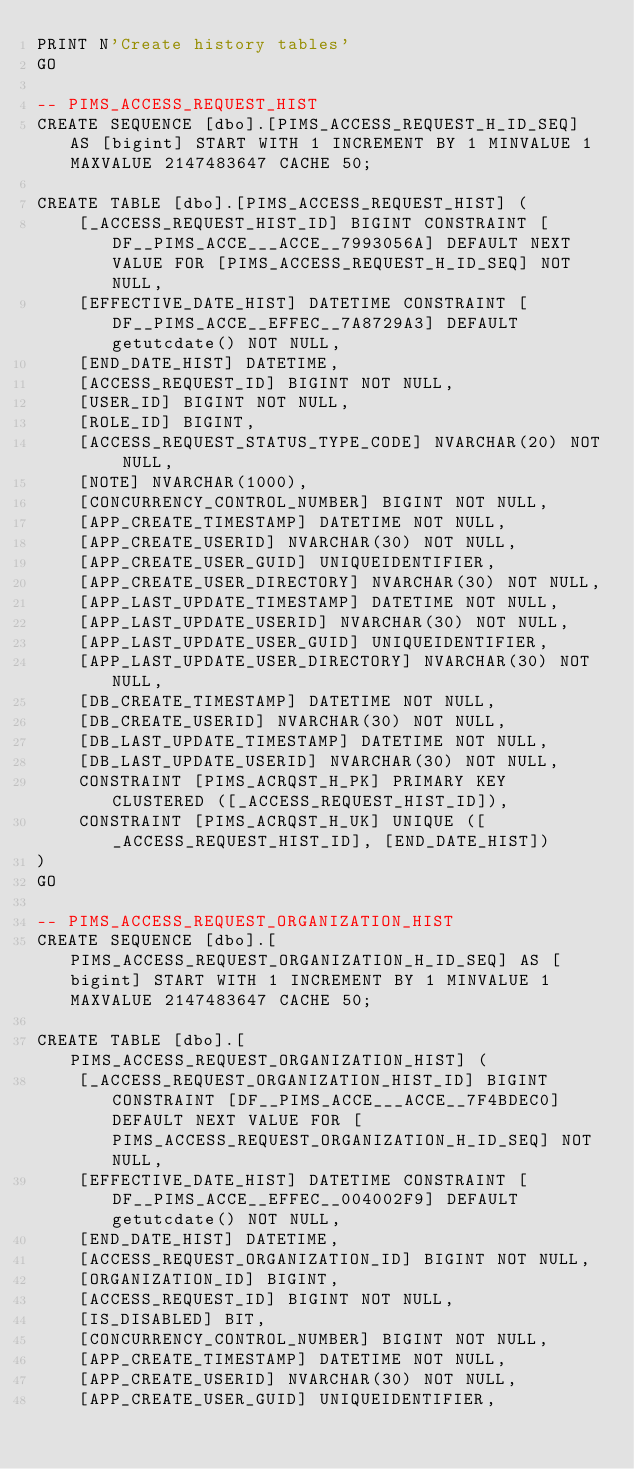<code> <loc_0><loc_0><loc_500><loc_500><_SQL_>PRINT N'Create history tables'
GO

-- PIMS_ACCESS_REQUEST_HIST
CREATE SEQUENCE [dbo].[PIMS_ACCESS_REQUEST_H_ID_SEQ] AS [bigint] START WITH 1 INCREMENT BY 1 MINVALUE 1 MAXVALUE 2147483647 CACHE 50;

CREATE TABLE [dbo].[PIMS_ACCESS_REQUEST_HIST] (
    [_ACCESS_REQUEST_HIST_ID] BIGINT CONSTRAINT [DF__PIMS_ACCE___ACCE__7993056A] DEFAULT NEXT VALUE FOR [PIMS_ACCESS_REQUEST_H_ID_SEQ] NOT NULL,
    [EFFECTIVE_DATE_HIST] DATETIME CONSTRAINT [DF__PIMS_ACCE__EFFEC__7A8729A3] DEFAULT getutcdate() NOT NULL,
    [END_DATE_HIST] DATETIME,
    [ACCESS_REQUEST_ID] BIGINT NOT NULL,
    [USER_ID] BIGINT NOT NULL,
    [ROLE_ID] BIGINT,
    [ACCESS_REQUEST_STATUS_TYPE_CODE] NVARCHAR(20) NOT NULL,
    [NOTE] NVARCHAR(1000),
    [CONCURRENCY_CONTROL_NUMBER] BIGINT NOT NULL,
    [APP_CREATE_TIMESTAMP] DATETIME NOT NULL,
    [APP_CREATE_USERID] NVARCHAR(30) NOT NULL,
    [APP_CREATE_USER_GUID] UNIQUEIDENTIFIER,
    [APP_CREATE_USER_DIRECTORY] NVARCHAR(30) NOT NULL,
    [APP_LAST_UPDATE_TIMESTAMP] DATETIME NOT NULL,
    [APP_LAST_UPDATE_USERID] NVARCHAR(30) NOT NULL,
    [APP_LAST_UPDATE_USER_GUID] UNIQUEIDENTIFIER,
    [APP_LAST_UPDATE_USER_DIRECTORY] NVARCHAR(30) NOT NULL,
    [DB_CREATE_TIMESTAMP] DATETIME NOT NULL,
    [DB_CREATE_USERID] NVARCHAR(30) NOT NULL,
    [DB_LAST_UPDATE_TIMESTAMP] DATETIME NOT NULL,
    [DB_LAST_UPDATE_USERID] NVARCHAR(30) NOT NULL,
    CONSTRAINT [PIMS_ACRQST_H_PK] PRIMARY KEY CLUSTERED ([_ACCESS_REQUEST_HIST_ID]),
    CONSTRAINT [PIMS_ACRQST_H_UK] UNIQUE ([_ACCESS_REQUEST_HIST_ID], [END_DATE_HIST])
)
GO

-- PIMS_ACCESS_REQUEST_ORGANIZATION_HIST
CREATE SEQUENCE [dbo].[PIMS_ACCESS_REQUEST_ORGANIZATION_H_ID_SEQ] AS [bigint] START WITH 1 INCREMENT BY 1 MINVALUE 1 MAXVALUE 2147483647 CACHE 50;

CREATE TABLE [dbo].[PIMS_ACCESS_REQUEST_ORGANIZATION_HIST] (
    [_ACCESS_REQUEST_ORGANIZATION_HIST_ID] BIGINT CONSTRAINT [DF__PIMS_ACCE___ACCE__7F4BDEC0] DEFAULT NEXT VALUE FOR [PIMS_ACCESS_REQUEST_ORGANIZATION_H_ID_SEQ] NOT NULL,
    [EFFECTIVE_DATE_HIST] DATETIME CONSTRAINT [DF__PIMS_ACCE__EFFEC__004002F9] DEFAULT getutcdate() NOT NULL,
    [END_DATE_HIST] DATETIME,
    [ACCESS_REQUEST_ORGANIZATION_ID] BIGINT NOT NULL,
    [ORGANIZATION_ID] BIGINT,
    [ACCESS_REQUEST_ID] BIGINT NOT NULL,
    [IS_DISABLED] BIT,
    [CONCURRENCY_CONTROL_NUMBER] BIGINT NOT NULL,
    [APP_CREATE_TIMESTAMP] DATETIME NOT NULL,
    [APP_CREATE_USERID] NVARCHAR(30) NOT NULL,
    [APP_CREATE_USER_GUID] UNIQUEIDENTIFIER,</code> 